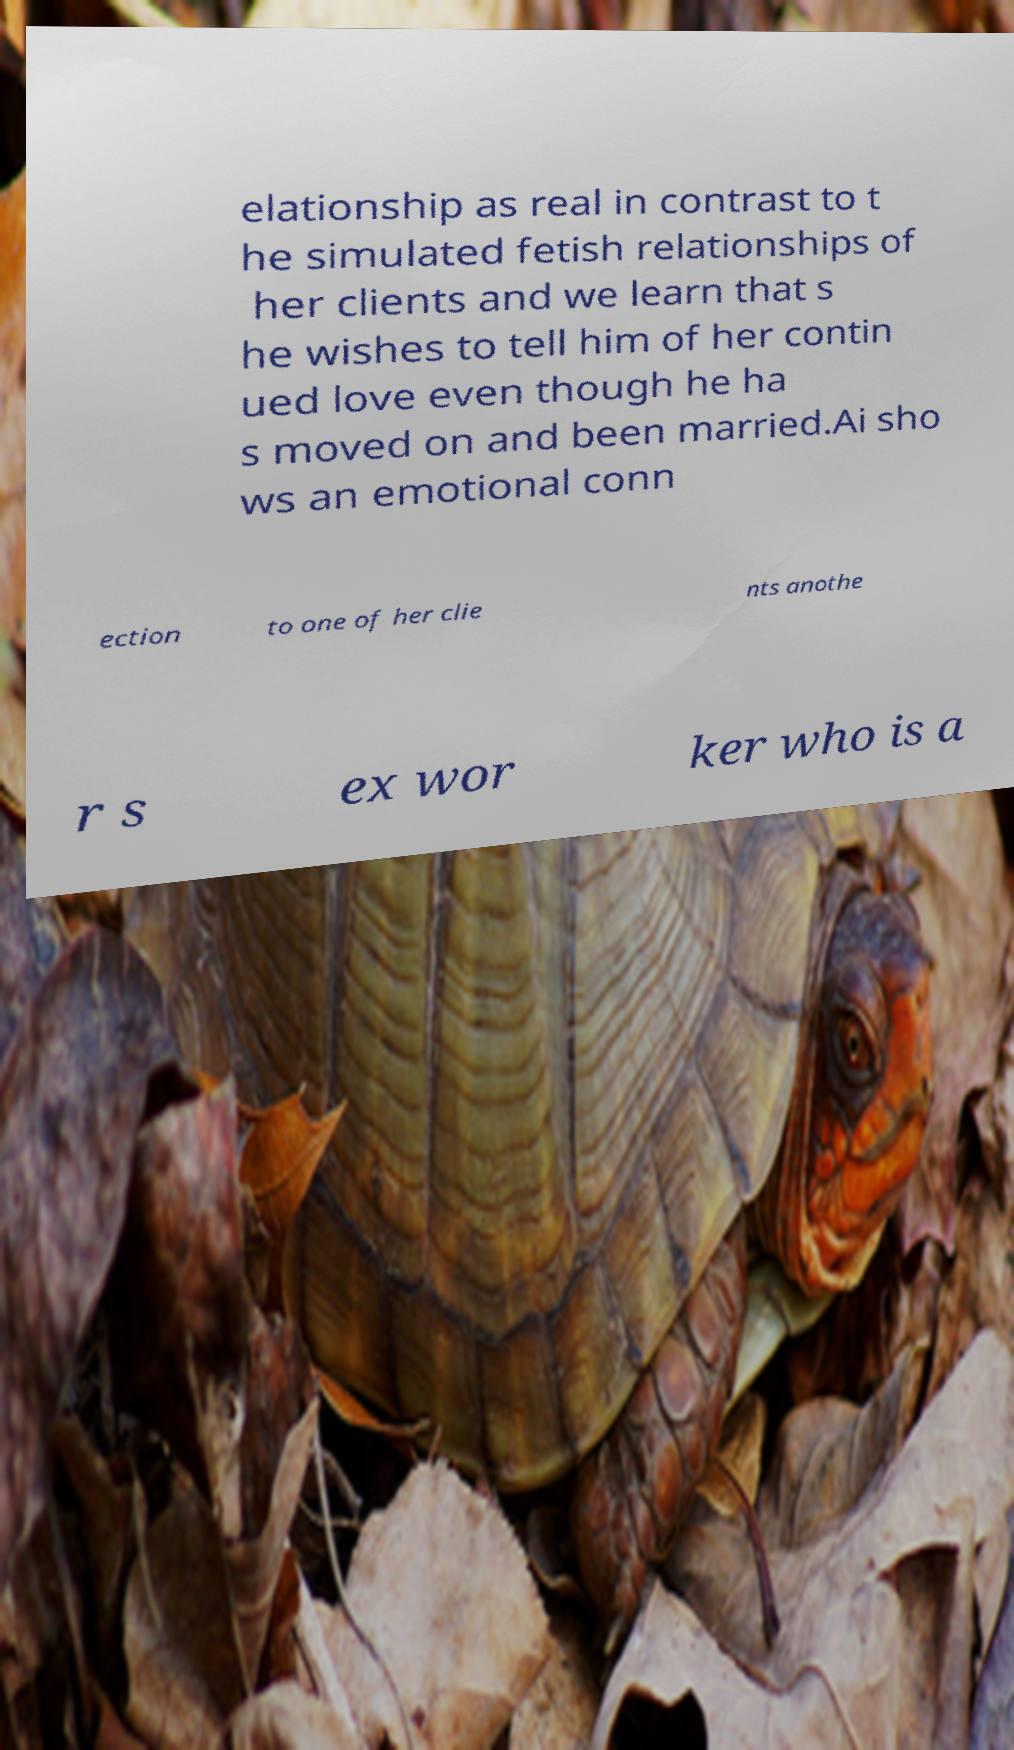Could you extract and type out the text from this image? elationship as real in contrast to t he simulated fetish relationships of her clients and we learn that s he wishes to tell him of her contin ued love even though he ha s moved on and been married.Ai sho ws an emotional conn ection to one of her clie nts anothe r s ex wor ker who is a 